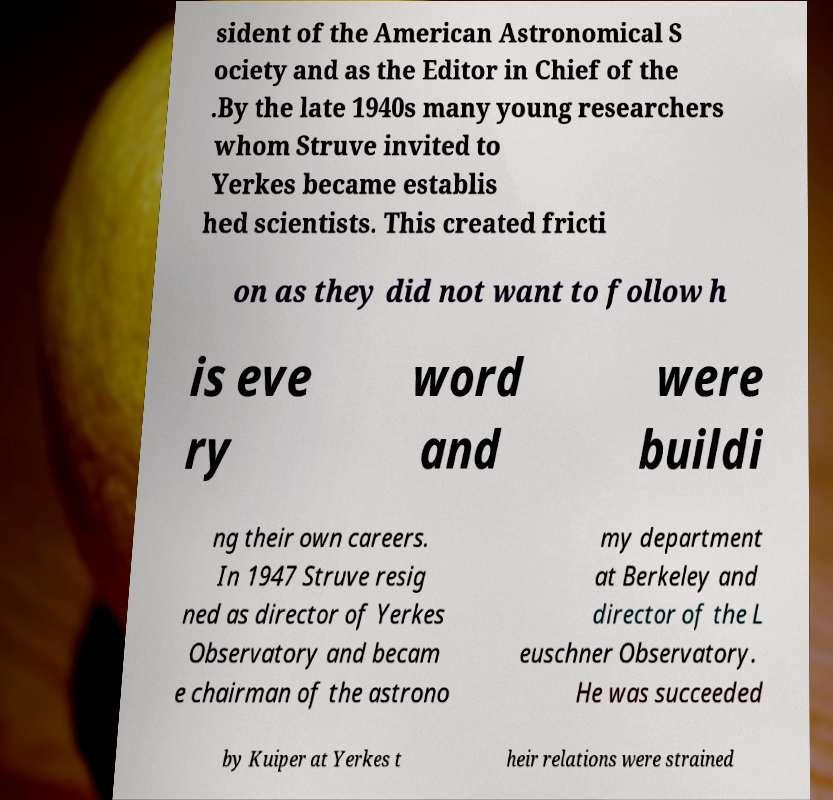There's text embedded in this image that I need extracted. Can you transcribe it verbatim? sident of the American Astronomical S ociety and as the Editor in Chief of the .By the late 1940s many young researchers whom Struve invited to Yerkes became establis hed scientists. This created fricti on as they did not want to follow h is eve ry word and were buildi ng their own careers. In 1947 Struve resig ned as director of Yerkes Observatory and becam e chairman of the astrono my department at Berkeley and director of the L euschner Observatory. He was succeeded by Kuiper at Yerkes t heir relations were strained 